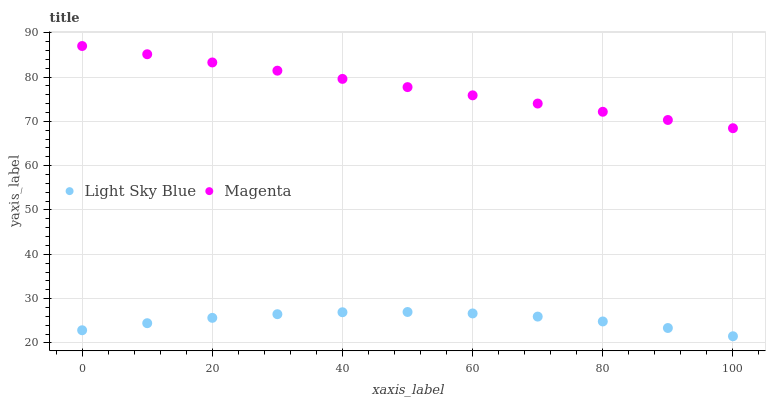Does Light Sky Blue have the minimum area under the curve?
Answer yes or no. Yes. Does Magenta have the maximum area under the curve?
Answer yes or no. Yes. Does Light Sky Blue have the maximum area under the curve?
Answer yes or no. No. Is Magenta the smoothest?
Answer yes or no. Yes. Is Light Sky Blue the roughest?
Answer yes or no. Yes. Is Light Sky Blue the smoothest?
Answer yes or no. No. Does Light Sky Blue have the lowest value?
Answer yes or no. Yes. Does Magenta have the highest value?
Answer yes or no. Yes. Does Light Sky Blue have the highest value?
Answer yes or no. No. Is Light Sky Blue less than Magenta?
Answer yes or no. Yes. Is Magenta greater than Light Sky Blue?
Answer yes or no. Yes. Does Light Sky Blue intersect Magenta?
Answer yes or no. No. 